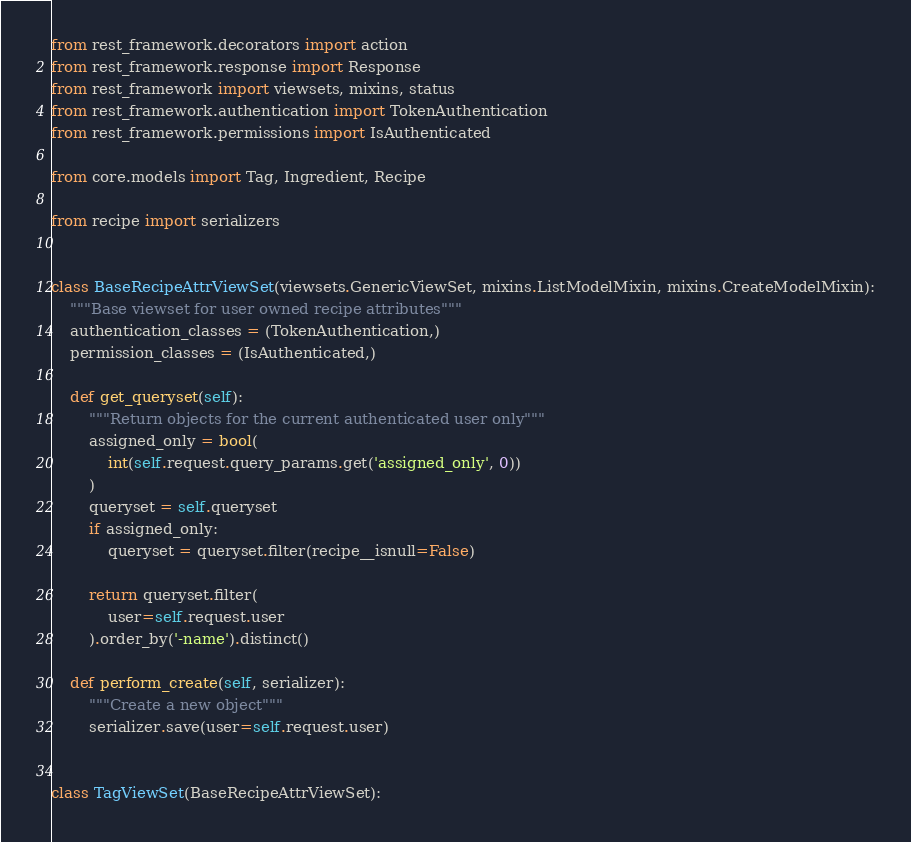Convert code to text. <code><loc_0><loc_0><loc_500><loc_500><_Python_>from rest_framework.decorators import action
from rest_framework.response import Response
from rest_framework import viewsets, mixins, status
from rest_framework.authentication import TokenAuthentication
from rest_framework.permissions import IsAuthenticated

from core.models import Tag, Ingredient, Recipe

from recipe import serializers


class BaseRecipeAttrViewSet(viewsets.GenericViewSet, mixins.ListModelMixin, mixins.CreateModelMixin):
    """Base viewset for user owned recipe attributes"""
    authentication_classes = (TokenAuthentication,)
    permission_classes = (IsAuthenticated,)

    def get_queryset(self):
        """Return objects for the current authenticated user only"""
        assigned_only = bool(
            int(self.request.query_params.get('assigned_only', 0))
        )
        queryset = self.queryset
        if assigned_only:
            queryset = queryset.filter(recipe__isnull=False)

        return queryset.filter(
            user=self.request.user
        ).order_by('-name').distinct()

    def perform_create(self, serializer):
        """Create a new object"""
        serializer.save(user=self.request.user)


class TagViewSet(BaseRecipeAttrViewSet):</code> 